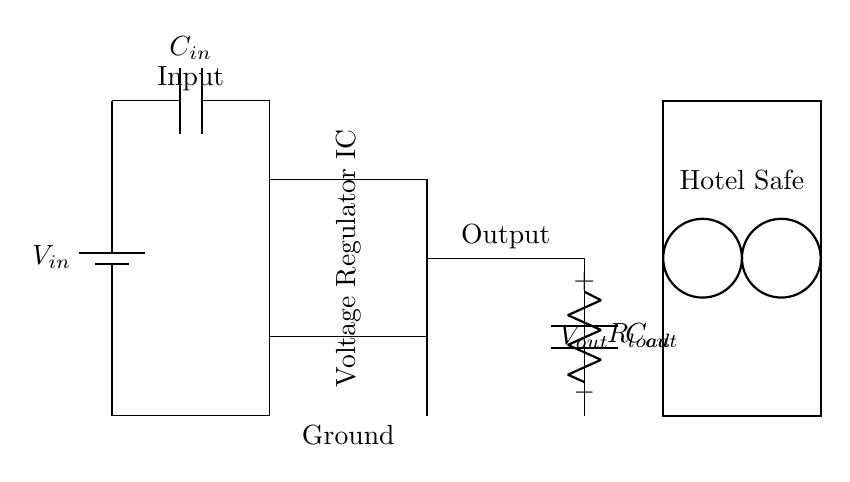What is the input component in this circuit? The input component is a battery represented by a symbol that shows the positive and negative terminals. It is labeled as V in, indicating the input voltage source.
Answer: Battery What type of circuit component is labeled as 'C in'? The component labeled as 'C in' is a capacitor, which is used to filter and stabilize the input voltage before it reaches the voltage regulator.
Answer: Capacitor What is the role of the voltage regulator in this circuit? The voltage regulator regulates the output voltage, ensuring that the voltage supplied to the load (hotel safe in this case) remains stable regardless of variations in the input voltage or load conditions.
Answer: Stabilization What is the output voltage of the circuit? The output voltage is not explicitly labeled in the diagram; however, it can be inferred from the intended operation, which is often a fixed voltage depending on the regulator used. In many designs, it could typically be 5 volts or similar.
Answer: Not specified What is the purpose of the load R load, and what does it represent? The load R load represents the electrical device being powered by the regulated output voltage; in this case, it symbolizes the electronic safe in the hotel room. This component converts electrical energy into some form of work or storage, like electronic data or locking mechanisms.
Answer: Hotel safe How many capacitors are present in this circuit, and what are their labels? There are two capacitors in the circuit, labeled as C in for the input capacitor and C out for the output capacitor. These capacitors help in filtering and stabilizing the voltage levels at the input and output sides of the voltage regulator, respectively.
Answer: Two (C in and C out) Which component provides a path to ground in this circuit? The ground connection is shown by the lines connecting from the battery through the regulator IC and to both capacitors and the load, indicating common return paths for voltage. The circuit ground often represents zero voltage potential in the design.
Answer: Ground 